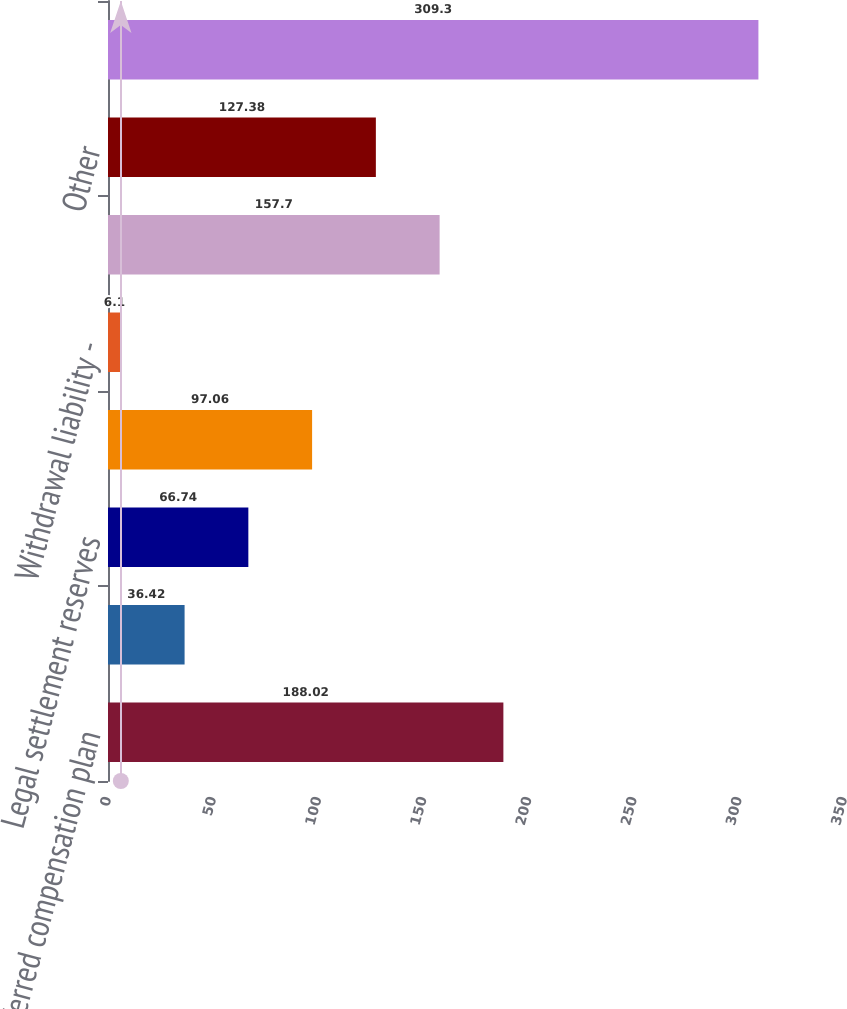Convert chart. <chart><loc_0><loc_0><loc_500><loc_500><bar_chart><fcel>Deferred compensation plan<fcel>Pension and other<fcel>Legal settlement reserves<fcel>Ceded insurance reserves<fcel>Withdrawal liability -<fcel>Contingent consideration and<fcel>Other<fcel>Total<nl><fcel>188.02<fcel>36.42<fcel>66.74<fcel>97.06<fcel>6.1<fcel>157.7<fcel>127.38<fcel>309.3<nl></chart> 